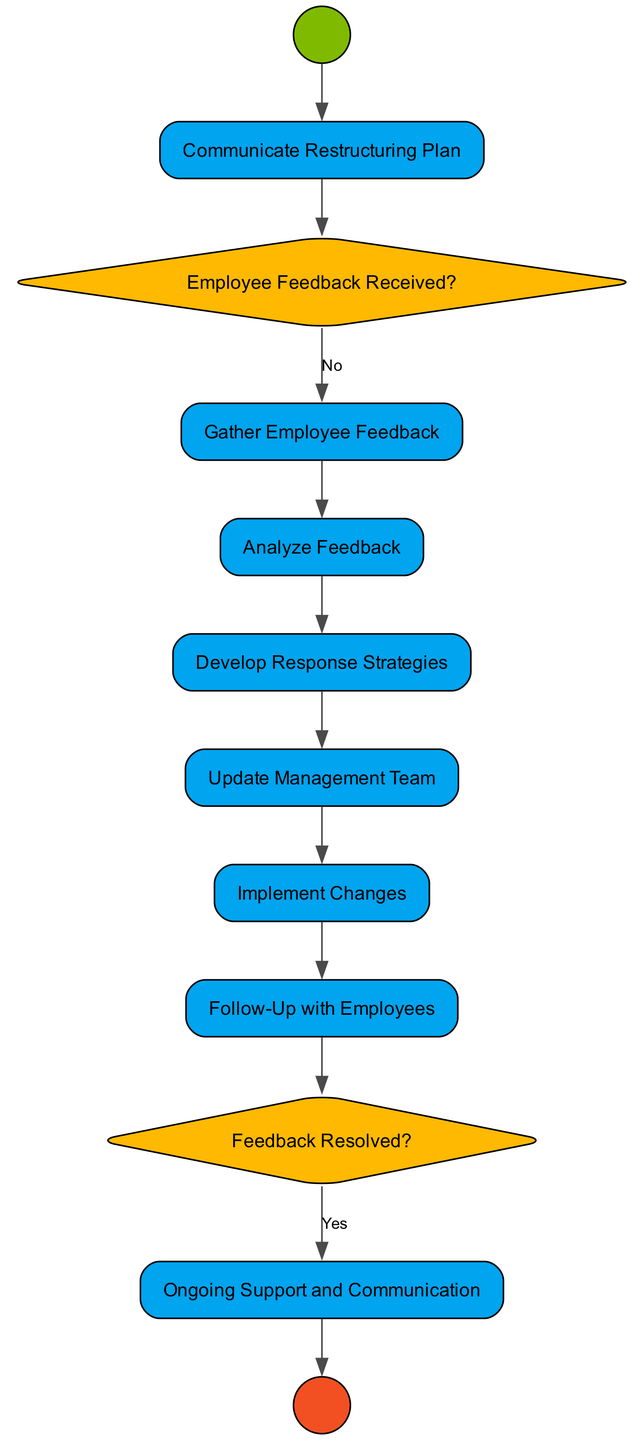What is the first activity in the diagram? The diagram starts with the "Communicate Restructuring Plan" activity immediately after the starting node.
Answer: Communicate Restructuring Plan How many decision nodes are in the diagram? Analyzing the diagram, there are two decision nodes: "Employee Feedback Received?" and "Feedback Resolved?".
Answer: 2 What is the final activity before the end node? The last activity before the ending node is "Ongoing Support and Communication". This can be identified by following the flow from all previous nodes.
Answer: Ongoing Support and Communication What action occurs if employee feedback is not received? If no feedback is received, the process continues directly to the "Update Management Team" activity, as indicated by the flow from the decision node.
Answer: Update Management Team What happens after the "Analyze Feedback" activity? Following the "Analyze Feedback" node, the next activity is "Develop Response Strategies", as it flows directly in sequence.
Answer: Develop Response Strategies What is the purpose of the "Gather Employee Feedback" activity? The purpose of the "Gather Employee Feedback" activity is to set up channels to collect feedback from employees regarding the restructuring plan.
Answer: Set up channels to gather feedback What occurs if the "Feedback Resolved?" decision node leads to "No"? If the feedback is not resolved, the next action would lead back to "Ongoing Support and Communication" to ensure continuous engagement with employees, indicating that further support is required.
Answer: Ongoing Support and Communication Which activity follows the "Implement Changes" activity? After the "Implement Changes" activity, the diagram shows a flow leading to the "Follow-Up with Employees" activity, indicating subsequent engagement after changes have been made.
Answer: Follow-Up with Employees What is the last node type before the end node? The last node before reaching the end node is an activity type, specifically "Ongoing Support and Communication".
Answer: Activity 